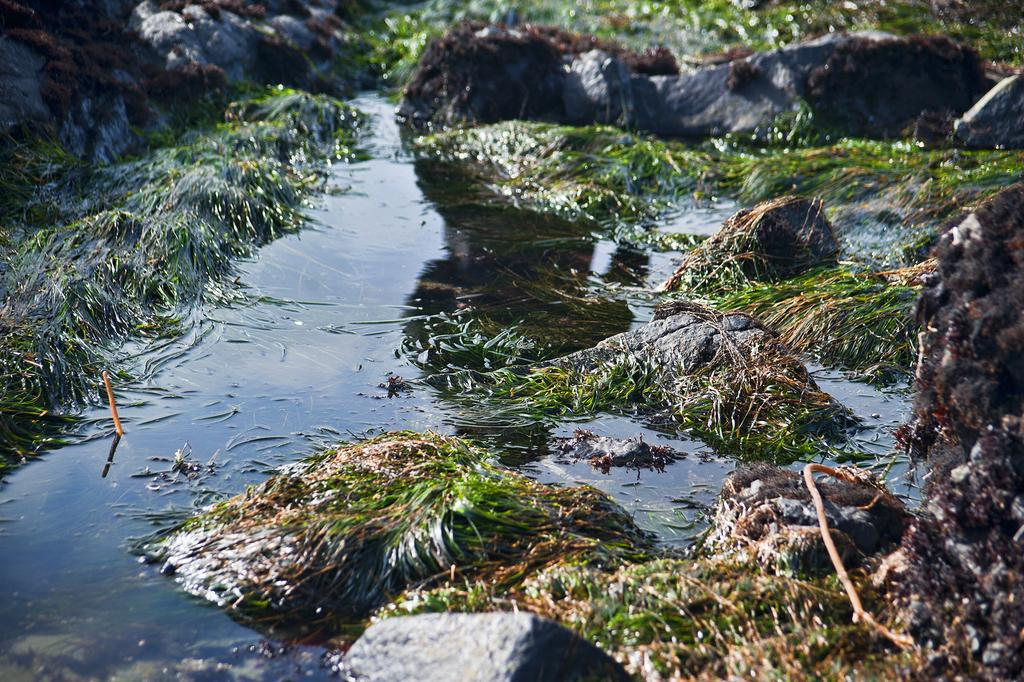What type of vegetation is present in the image? There is grass in the image. What other natural elements can be seen in the image? There are rocks in the image. Is there any water visible in the image? Yes, there is a water body in the image. How many babies are present in the image? There are no babies present in the image. Is there a lawyer working on a case in the image? There is no lawyer or any legal activity depicted in the image. 